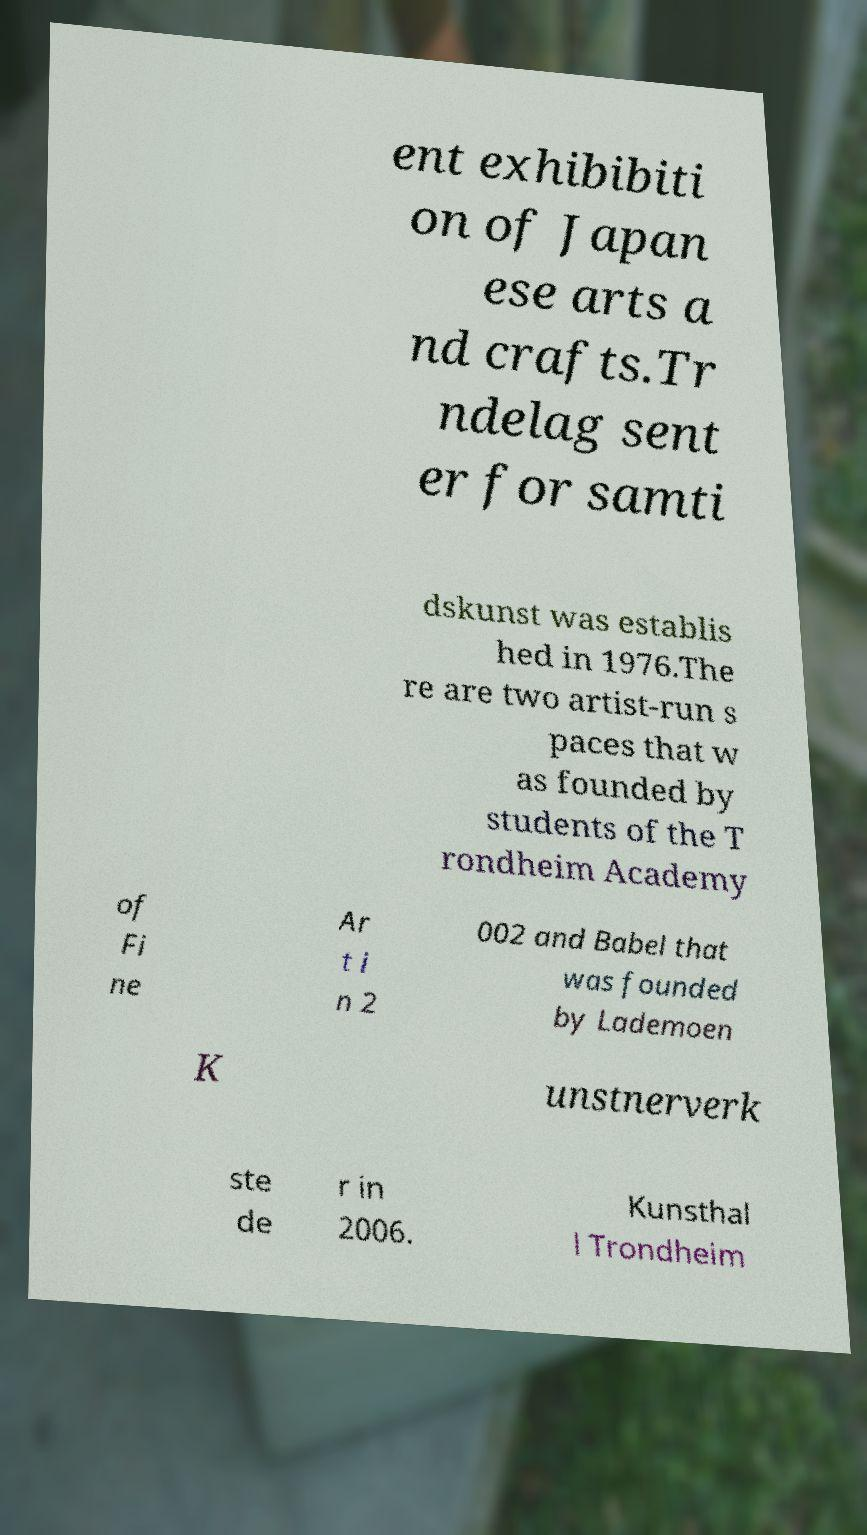I need the written content from this picture converted into text. Can you do that? ent exhibibiti on of Japan ese arts a nd crafts.Tr ndelag sent er for samti dskunst was establis hed in 1976.The re are two artist-run s paces that w as founded by students of the T rondheim Academy of Fi ne Ar t i n 2 002 and Babel that was founded by Lademoen K unstnerverk ste de r in 2006. Kunsthal l Trondheim 